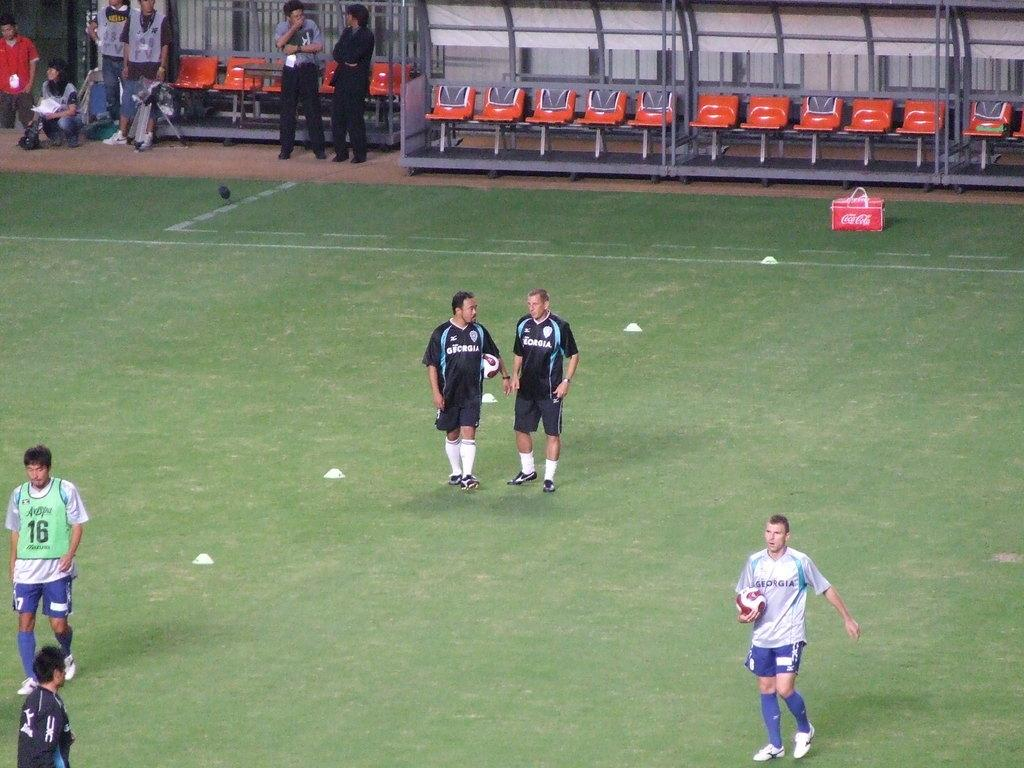<image>
Summarize the visual content of the image. The cooler is carrying the soda coca cola inside. 